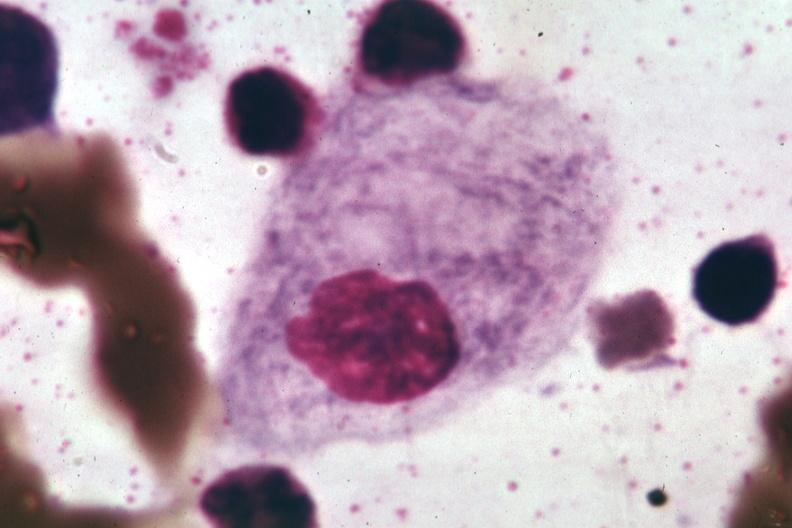does fat necrosis show wrights?
Answer the question using a single word or phrase. No 